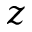Convert formula to latex. <formula><loc_0><loc_0><loc_500><loc_500>z</formula> 